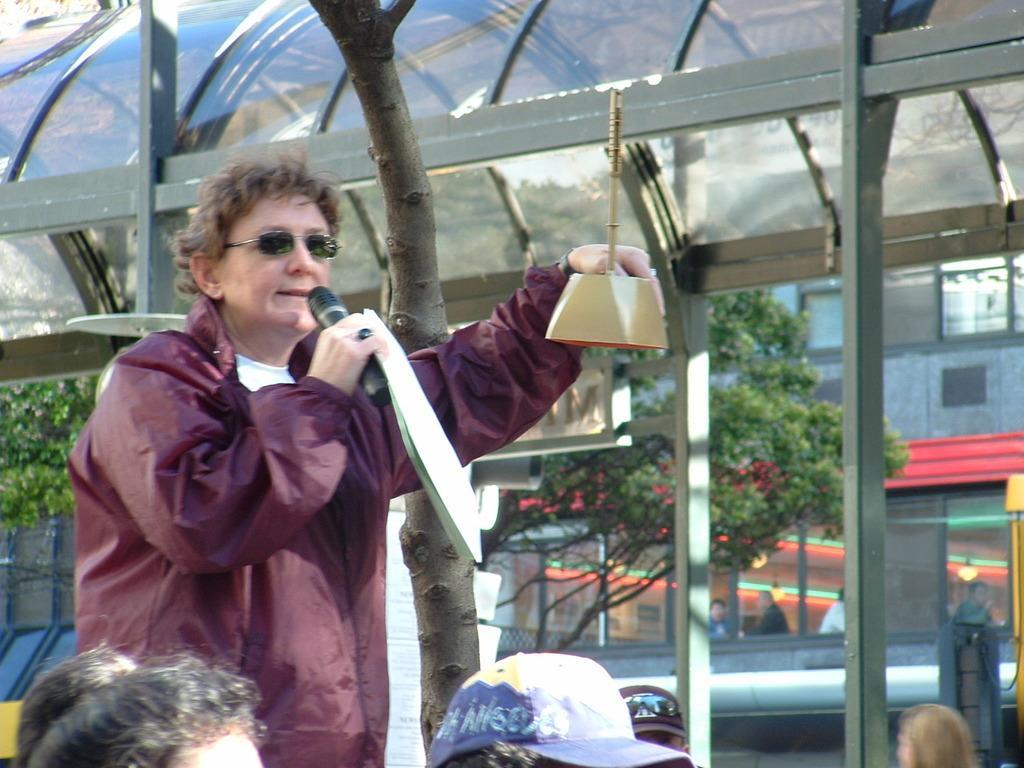Can you describe this image briefly? In this image I can see a person wearing jacket is standing and holding a microphone and few other objects in hands. I can see few other persons heads. In the background I can see few trees, few persons, a building and a shed. 